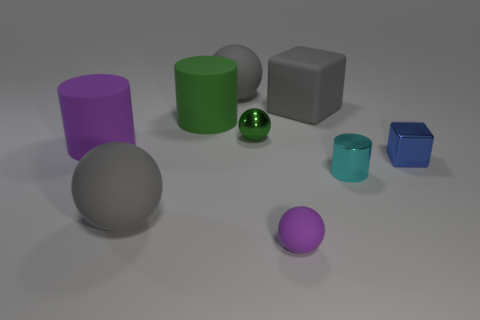How do the colors of the objects compare? The colors of the objects in the image vary considerably, providing a pleasant contrast. We have vivid colored objects such as the purple cylinder, green sphere, and blue cube, among others. These are offset by more neutral tones in the gray rubber block and the matte gray sphere. The diversity in color helps to differentiate the objects and adds visual interest to the scene. 